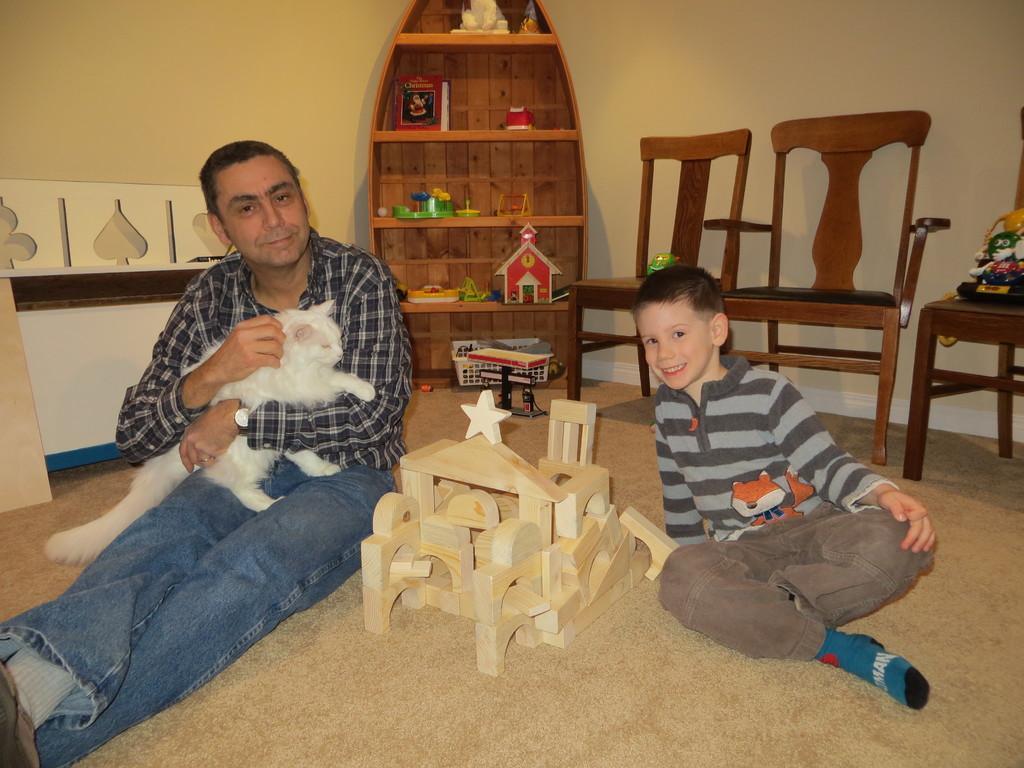How would you summarize this image in a sentence or two? Here we can see two persons are sitting on the floor and smiling, and holding a cat in his hands, and at back here are the chairs, and here is the wall. 